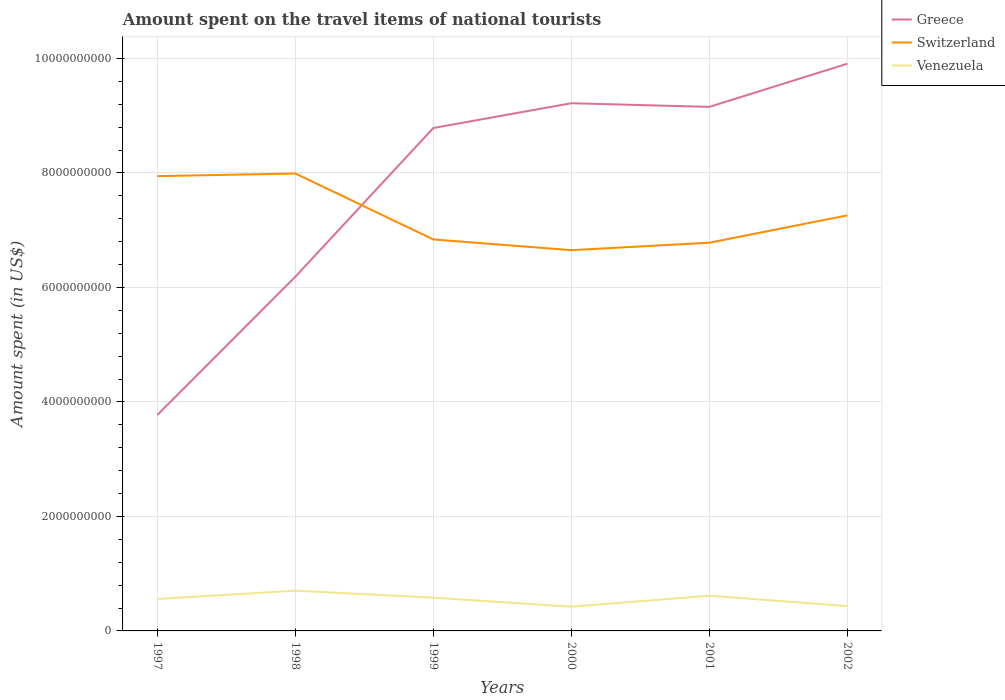How many different coloured lines are there?
Provide a short and direct response. 3. Is the number of lines equal to the number of legend labels?
Your answer should be very brief. Yes. Across all years, what is the maximum amount spent on the travel items of national tourists in Venezuela?
Your response must be concise. 4.23e+08. What is the total amount spent on the travel items of national tourists in Venezuela in the graph?
Your answer should be very brief. 2.80e+08. What is the difference between the highest and the second highest amount spent on the travel items of national tourists in Greece?
Your answer should be compact. 6.14e+09. How many lines are there?
Keep it short and to the point. 3. What is the difference between two consecutive major ticks on the Y-axis?
Provide a short and direct response. 2.00e+09. Are the values on the major ticks of Y-axis written in scientific E-notation?
Offer a terse response. No. Does the graph contain grids?
Keep it short and to the point. Yes. How many legend labels are there?
Provide a short and direct response. 3. What is the title of the graph?
Offer a terse response. Amount spent on the travel items of national tourists. Does "Cayman Islands" appear as one of the legend labels in the graph?
Give a very brief answer. No. What is the label or title of the X-axis?
Make the answer very short. Years. What is the label or title of the Y-axis?
Your answer should be compact. Amount spent (in US$). What is the Amount spent (in US$) of Greece in 1997?
Offer a very short reply. 3.77e+09. What is the Amount spent (in US$) in Switzerland in 1997?
Provide a short and direct response. 7.94e+09. What is the Amount spent (in US$) of Venezuela in 1997?
Provide a short and direct response. 5.58e+08. What is the Amount spent (in US$) of Greece in 1998?
Offer a very short reply. 6.19e+09. What is the Amount spent (in US$) in Switzerland in 1998?
Ensure brevity in your answer.  7.99e+09. What is the Amount spent (in US$) in Venezuela in 1998?
Your answer should be compact. 7.03e+08. What is the Amount spent (in US$) in Greece in 1999?
Provide a succinct answer. 8.79e+09. What is the Amount spent (in US$) in Switzerland in 1999?
Offer a terse response. 6.84e+09. What is the Amount spent (in US$) in Venezuela in 1999?
Your response must be concise. 5.81e+08. What is the Amount spent (in US$) of Greece in 2000?
Make the answer very short. 9.22e+09. What is the Amount spent (in US$) in Switzerland in 2000?
Provide a succinct answer. 6.65e+09. What is the Amount spent (in US$) in Venezuela in 2000?
Give a very brief answer. 4.23e+08. What is the Amount spent (in US$) of Greece in 2001?
Your answer should be compact. 9.16e+09. What is the Amount spent (in US$) in Switzerland in 2001?
Make the answer very short. 6.78e+09. What is the Amount spent (in US$) of Venezuela in 2001?
Provide a short and direct response. 6.15e+08. What is the Amount spent (in US$) in Greece in 2002?
Your response must be concise. 9.91e+09. What is the Amount spent (in US$) in Switzerland in 2002?
Your response must be concise. 7.26e+09. What is the Amount spent (in US$) of Venezuela in 2002?
Offer a very short reply. 4.34e+08. Across all years, what is the maximum Amount spent (in US$) in Greece?
Provide a short and direct response. 9.91e+09. Across all years, what is the maximum Amount spent (in US$) of Switzerland?
Your response must be concise. 7.99e+09. Across all years, what is the maximum Amount spent (in US$) in Venezuela?
Offer a terse response. 7.03e+08. Across all years, what is the minimum Amount spent (in US$) in Greece?
Your answer should be compact. 3.77e+09. Across all years, what is the minimum Amount spent (in US$) in Switzerland?
Your response must be concise. 6.65e+09. Across all years, what is the minimum Amount spent (in US$) in Venezuela?
Keep it short and to the point. 4.23e+08. What is the total Amount spent (in US$) of Greece in the graph?
Provide a short and direct response. 4.70e+1. What is the total Amount spent (in US$) in Switzerland in the graph?
Offer a terse response. 4.35e+1. What is the total Amount spent (in US$) of Venezuela in the graph?
Provide a succinct answer. 3.31e+09. What is the difference between the Amount spent (in US$) in Greece in 1997 and that in 1998?
Your answer should be compact. -2.42e+09. What is the difference between the Amount spent (in US$) of Switzerland in 1997 and that in 1998?
Offer a terse response. -4.60e+07. What is the difference between the Amount spent (in US$) in Venezuela in 1997 and that in 1998?
Provide a succinct answer. -1.45e+08. What is the difference between the Amount spent (in US$) of Greece in 1997 and that in 1999?
Provide a succinct answer. -5.01e+09. What is the difference between the Amount spent (in US$) in Switzerland in 1997 and that in 1999?
Offer a very short reply. 1.11e+09. What is the difference between the Amount spent (in US$) of Venezuela in 1997 and that in 1999?
Offer a very short reply. -2.30e+07. What is the difference between the Amount spent (in US$) of Greece in 1997 and that in 2000?
Offer a terse response. -5.45e+09. What is the difference between the Amount spent (in US$) in Switzerland in 1997 and that in 2000?
Your answer should be compact. 1.29e+09. What is the difference between the Amount spent (in US$) of Venezuela in 1997 and that in 2000?
Provide a succinct answer. 1.35e+08. What is the difference between the Amount spent (in US$) of Greece in 1997 and that in 2001?
Provide a succinct answer. -5.38e+09. What is the difference between the Amount spent (in US$) of Switzerland in 1997 and that in 2001?
Offer a terse response. 1.16e+09. What is the difference between the Amount spent (in US$) of Venezuela in 1997 and that in 2001?
Your response must be concise. -5.70e+07. What is the difference between the Amount spent (in US$) in Greece in 1997 and that in 2002?
Offer a terse response. -6.14e+09. What is the difference between the Amount spent (in US$) in Switzerland in 1997 and that in 2002?
Give a very brief answer. 6.85e+08. What is the difference between the Amount spent (in US$) in Venezuela in 1997 and that in 2002?
Your answer should be very brief. 1.24e+08. What is the difference between the Amount spent (in US$) of Greece in 1998 and that in 1999?
Ensure brevity in your answer.  -2.60e+09. What is the difference between the Amount spent (in US$) in Switzerland in 1998 and that in 1999?
Your answer should be compact. 1.15e+09. What is the difference between the Amount spent (in US$) in Venezuela in 1998 and that in 1999?
Offer a very short reply. 1.22e+08. What is the difference between the Amount spent (in US$) in Greece in 1998 and that in 2000?
Offer a very short reply. -3.03e+09. What is the difference between the Amount spent (in US$) of Switzerland in 1998 and that in 2000?
Give a very brief answer. 1.34e+09. What is the difference between the Amount spent (in US$) of Venezuela in 1998 and that in 2000?
Offer a terse response. 2.80e+08. What is the difference between the Amount spent (in US$) in Greece in 1998 and that in 2001?
Ensure brevity in your answer.  -2.97e+09. What is the difference between the Amount spent (in US$) of Switzerland in 1998 and that in 2001?
Offer a terse response. 1.21e+09. What is the difference between the Amount spent (in US$) of Venezuela in 1998 and that in 2001?
Offer a very short reply. 8.80e+07. What is the difference between the Amount spent (in US$) in Greece in 1998 and that in 2002?
Offer a very short reply. -3.72e+09. What is the difference between the Amount spent (in US$) in Switzerland in 1998 and that in 2002?
Your answer should be compact. 7.31e+08. What is the difference between the Amount spent (in US$) of Venezuela in 1998 and that in 2002?
Your answer should be very brief. 2.69e+08. What is the difference between the Amount spent (in US$) in Greece in 1999 and that in 2000?
Give a very brief answer. -4.33e+08. What is the difference between the Amount spent (in US$) of Switzerland in 1999 and that in 2000?
Give a very brief answer. 1.87e+08. What is the difference between the Amount spent (in US$) in Venezuela in 1999 and that in 2000?
Your answer should be compact. 1.58e+08. What is the difference between the Amount spent (in US$) of Greece in 1999 and that in 2001?
Provide a succinct answer. -3.69e+08. What is the difference between the Amount spent (in US$) of Switzerland in 1999 and that in 2001?
Give a very brief answer. 5.70e+07. What is the difference between the Amount spent (in US$) in Venezuela in 1999 and that in 2001?
Offer a very short reply. -3.40e+07. What is the difference between the Amount spent (in US$) of Greece in 1999 and that in 2002?
Make the answer very short. -1.12e+09. What is the difference between the Amount spent (in US$) of Switzerland in 1999 and that in 2002?
Provide a succinct answer. -4.21e+08. What is the difference between the Amount spent (in US$) of Venezuela in 1999 and that in 2002?
Your response must be concise. 1.47e+08. What is the difference between the Amount spent (in US$) in Greece in 2000 and that in 2001?
Provide a short and direct response. 6.40e+07. What is the difference between the Amount spent (in US$) of Switzerland in 2000 and that in 2001?
Provide a succinct answer. -1.30e+08. What is the difference between the Amount spent (in US$) of Venezuela in 2000 and that in 2001?
Make the answer very short. -1.92e+08. What is the difference between the Amount spent (in US$) of Greece in 2000 and that in 2002?
Give a very brief answer. -6.90e+08. What is the difference between the Amount spent (in US$) of Switzerland in 2000 and that in 2002?
Your answer should be very brief. -6.08e+08. What is the difference between the Amount spent (in US$) of Venezuela in 2000 and that in 2002?
Your response must be concise. -1.10e+07. What is the difference between the Amount spent (in US$) in Greece in 2001 and that in 2002?
Give a very brief answer. -7.54e+08. What is the difference between the Amount spent (in US$) in Switzerland in 2001 and that in 2002?
Keep it short and to the point. -4.78e+08. What is the difference between the Amount spent (in US$) in Venezuela in 2001 and that in 2002?
Your answer should be compact. 1.81e+08. What is the difference between the Amount spent (in US$) of Greece in 1997 and the Amount spent (in US$) of Switzerland in 1998?
Make the answer very short. -4.22e+09. What is the difference between the Amount spent (in US$) in Greece in 1997 and the Amount spent (in US$) in Venezuela in 1998?
Give a very brief answer. 3.07e+09. What is the difference between the Amount spent (in US$) of Switzerland in 1997 and the Amount spent (in US$) of Venezuela in 1998?
Your answer should be compact. 7.24e+09. What is the difference between the Amount spent (in US$) in Greece in 1997 and the Amount spent (in US$) in Switzerland in 1999?
Offer a very short reply. -3.07e+09. What is the difference between the Amount spent (in US$) in Greece in 1997 and the Amount spent (in US$) in Venezuela in 1999?
Offer a very short reply. 3.19e+09. What is the difference between the Amount spent (in US$) of Switzerland in 1997 and the Amount spent (in US$) of Venezuela in 1999?
Provide a short and direct response. 7.36e+09. What is the difference between the Amount spent (in US$) of Greece in 1997 and the Amount spent (in US$) of Switzerland in 2000?
Provide a succinct answer. -2.88e+09. What is the difference between the Amount spent (in US$) in Greece in 1997 and the Amount spent (in US$) in Venezuela in 2000?
Give a very brief answer. 3.35e+09. What is the difference between the Amount spent (in US$) of Switzerland in 1997 and the Amount spent (in US$) of Venezuela in 2000?
Your response must be concise. 7.52e+09. What is the difference between the Amount spent (in US$) in Greece in 1997 and the Amount spent (in US$) in Switzerland in 2001?
Your answer should be compact. -3.01e+09. What is the difference between the Amount spent (in US$) in Greece in 1997 and the Amount spent (in US$) in Venezuela in 2001?
Your answer should be compact. 3.16e+09. What is the difference between the Amount spent (in US$) in Switzerland in 1997 and the Amount spent (in US$) in Venezuela in 2001?
Offer a terse response. 7.33e+09. What is the difference between the Amount spent (in US$) of Greece in 1997 and the Amount spent (in US$) of Switzerland in 2002?
Make the answer very short. -3.49e+09. What is the difference between the Amount spent (in US$) of Greece in 1997 and the Amount spent (in US$) of Venezuela in 2002?
Offer a very short reply. 3.34e+09. What is the difference between the Amount spent (in US$) in Switzerland in 1997 and the Amount spent (in US$) in Venezuela in 2002?
Provide a succinct answer. 7.51e+09. What is the difference between the Amount spent (in US$) of Greece in 1998 and the Amount spent (in US$) of Switzerland in 1999?
Keep it short and to the point. -6.51e+08. What is the difference between the Amount spent (in US$) of Greece in 1998 and the Amount spent (in US$) of Venezuela in 1999?
Your answer should be very brief. 5.61e+09. What is the difference between the Amount spent (in US$) in Switzerland in 1998 and the Amount spent (in US$) in Venezuela in 1999?
Your response must be concise. 7.41e+09. What is the difference between the Amount spent (in US$) of Greece in 1998 and the Amount spent (in US$) of Switzerland in 2000?
Your answer should be compact. -4.64e+08. What is the difference between the Amount spent (in US$) of Greece in 1998 and the Amount spent (in US$) of Venezuela in 2000?
Keep it short and to the point. 5.76e+09. What is the difference between the Amount spent (in US$) in Switzerland in 1998 and the Amount spent (in US$) in Venezuela in 2000?
Keep it short and to the point. 7.57e+09. What is the difference between the Amount spent (in US$) in Greece in 1998 and the Amount spent (in US$) in Switzerland in 2001?
Provide a succinct answer. -5.94e+08. What is the difference between the Amount spent (in US$) of Greece in 1998 and the Amount spent (in US$) of Venezuela in 2001?
Your response must be concise. 5.57e+09. What is the difference between the Amount spent (in US$) in Switzerland in 1998 and the Amount spent (in US$) in Venezuela in 2001?
Make the answer very short. 7.38e+09. What is the difference between the Amount spent (in US$) in Greece in 1998 and the Amount spent (in US$) in Switzerland in 2002?
Ensure brevity in your answer.  -1.07e+09. What is the difference between the Amount spent (in US$) of Greece in 1998 and the Amount spent (in US$) of Venezuela in 2002?
Your response must be concise. 5.75e+09. What is the difference between the Amount spent (in US$) in Switzerland in 1998 and the Amount spent (in US$) in Venezuela in 2002?
Offer a terse response. 7.56e+09. What is the difference between the Amount spent (in US$) of Greece in 1999 and the Amount spent (in US$) of Switzerland in 2000?
Give a very brief answer. 2.13e+09. What is the difference between the Amount spent (in US$) of Greece in 1999 and the Amount spent (in US$) of Venezuela in 2000?
Give a very brief answer. 8.36e+09. What is the difference between the Amount spent (in US$) in Switzerland in 1999 and the Amount spent (in US$) in Venezuela in 2000?
Ensure brevity in your answer.  6.42e+09. What is the difference between the Amount spent (in US$) in Greece in 1999 and the Amount spent (in US$) in Switzerland in 2001?
Ensure brevity in your answer.  2.00e+09. What is the difference between the Amount spent (in US$) of Greece in 1999 and the Amount spent (in US$) of Venezuela in 2001?
Your answer should be very brief. 8.17e+09. What is the difference between the Amount spent (in US$) in Switzerland in 1999 and the Amount spent (in US$) in Venezuela in 2001?
Your response must be concise. 6.22e+09. What is the difference between the Amount spent (in US$) of Greece in 1999 and the Amount spent (in US$) of Switzerland in 2002?
Ensure brevity in your answer.  1.53e+09. What is the difference between the Amount spent (in US$) in Greece in 1999 and the Amount spent (in US$) in Venezuela in 2002?
Offer a terse response. 8.35e+09. What is the difference between the Amount spent (in US$) in Switzerland in 1999 and the Amount spent (in US$) in Venezuela in 2002?
Provide a succinct answer. 6.40e+09. What is the difference between the Amount spent (in US$) in Greece in 2000 and the Amount spent (in US$) in Switzerland in 2001?
Offer a very short reply. 2.44e+09. What is the difference between the Amount spent (in US$) of Greece in 2000 and the Amount spent (in US$) of Venezuela in 2001?
Your answer should be very brief. 8.60e+09. What is the difference between the Amount spent (in US$) of Switzerland in 2000 and the Amount spent (in US$) of Venezuela in 2001?
Your answer should be very brief. 6.04e+09. What is the difference between the Amount spent (in US$) in Greece in 2000 and the Amount spent (in US$) in Switzerland in 2002?
Your answer should be compact. 1.96e+09. What is the difference between the Amount spent (in US$) of Greece in 2000 and the Amount spent (in US$) of Venezuela in 2002?
Ensure brevity in your answer.  8.78e+09. What is the difference between the Amount spent (in US$) in Switzerland in 2000 and the Amount spent (in US$) in Venezuela in 2002?
Keep it short and to the point. 6.22e+09. What is the difference between the Amount spent (in US$) of Greece in 2001 and the Amount spent (in US$) of Switzerland in 2002?
Provide a succinct answer. 1.90e+09. What is the difference between the Amount spent (in US$) of Greece in 2001 and the Amount spent (in US$) of Venezuela in 2002?
Give a very brief answer. 8.72e+09. What is the difference between the Amount spent (in US$) in Switzerland in 2001 and the Amount spent (in US$) in Venezuela in 2002?
Your response must be concise. 6.35e+09. What is the average Amount spent (in US$) in Greece per year?
Keep it short and to the point. 7.84e+09. What is the average Amount spent (in US$) in Switzerland per year?
Ensure brevity in your answer.  7.24e+09. What is the average Amount spent (in US$) of Venezuela per year?
Your response must be concise. 5.52e+08. In the year 1997, what is the difference between the Amount spent (in US$) in Greece and Amount spent (in US$) in Switzerland?
Make the answer very short. -4.17e+09. In the year 1997, what is the difference between the Amount spent (in US$) in Greece and Amount spent (in US$) in Venezuela?
Provide a short and direct response. 3.22e+09. In the year 1997, what is the difference between the Amount spent (in US$) of Switzerland and Amount spent (in US$) of Venezuela?
Keep it short and to the point. 7.39e+09. In the year 1998, what is the difference between the Amount spent (in US$) of Greece and Amount spent (in US$) of Switzerland?
Ensure brevity in your answer.  -1.80e+09. In the year 1998, what is the difference between the Amount spent (in US$) in Greece and Amount spent (in US$) in Venezuela?
Your answer should be compact. 5.48e+09. In the year 1998, what is the difference between the Amount spent (in US$) in Switzerland and Amount spent (in US$) in Venezuela?
Your response must be concise. 7.29e+09. In the year 1999, what is the difference between the Amount spent (in US$) in Greece and Amount spent (in US$) in Switzerland?
Make the answer very short. 1.95e+09. In the year 1999, what is the difference between the Amount spent (in US$) of Greece and Amount spent (in US$) of Venezuela?
Your answer should be compact. 8.20e+09. In the year 1999, what is the difference between the Amount spent (in US$) of Switzerland and Amount spent (in US$) of Venezuela?
Ensure brevity in your answer.  6.26e+09. In the year 2000, what is the difference between the Amount spent (in US$) of Greece and Amount spent (in US$) of Switzerland?
Offer a very short reply. 2.57e+09. In the year 2000, what is the difference between the Amount spent (in US$) in Greece and Amount spent (in US$) in Venezuela?
Make the answer very short. 8.80e+09. In the year 2000, what is the difference between the Amount spent (in US$) in Switzerland and Amount spent (in US$) in Venezuela?
Offer a very short reply. 6.23e+09. In the year 2001, what is the difference between the Amount spent (in US$) in Greece and Amount spent (in US$) in Switzerland?
Your response must be concise. 2.37e+09. In the year 2001, what is the difference between the Amount spent (in US$) in Greece and Amount spent (in US$) in Venezuela?
Keep it short and to the point. 8.54e+09. In the year 2001, what is the difference between the Amount spent (in US$) of Switzerland and Amount spent (in US$) of Venezuela?
Offer a very short reply. 6.17e+09. In the year 2002, what is the difference between the Amount spent (in US$) of Greece and Amount spent (in US$) of Switzerland?
Give a very brief answer. 2.65e+09. In the year 2002, what is the difference between the Amount spent (in US$) in Greece and Amount spent (in US$) in Venezuela?
Provide a succinct answer. 9.48e+09. In the year 2002, what is the difference between the Amount spent (in US$) in Switzerland and Amount spent (in US$) in Venezuela?
Offer a terse response. 6.83e+09. What is the ratio of the Amount spent (in US$) in Greece in 1997 to that in 1998?
Give a very brief answer. 0.61. What is the ratio of the Amount spent (in US$) of Switzerland in 1997 to that in 1998?
Provide a succinct answer. 0.99. What is the ratio of the Amount spent (in US$) in Venezuela in 1997 to that in 1998?
Your response must be concise. 0.79. What is the ratio of the Amount spent (in US$) in Greece in 1997 to that in 1999?
Offer a terse response. 0.43. What is the ratio of the Amount spent (in US$) of Switzerland in 1997 to that in 1999?
Ensure brevity in your answer.  1.16. What is the ratio of the Amount spent (in US$) of Venezuela in 1997 to that in 1999?
Give a very brief answer. 0.96. What is the ratio of the Amount spent (in US$) in Greece in 1997 to that in 2000?
Offer a terse response. 0.41. What is the ratio of the Amount spent (in US$) in Switzerland in 1997 to that in 2000?
Offer a very short reply. 1.19. What is the ratio of the Amount spent (in US$) in Venezuela in 1997 to that in 2000?
Keep it short and to the point. 1.32. What is the ratio of the Amount spent (in US$) in Greece in 1997 to that in 2001?
Make the answer very short. 0.41. What is the ratio of the Amount spent (in US$) in Switzerland in 1997 to that in 2001?
Make the answer very short. 1.17. What is the ratio of the Amount spent (in US$) of Venezuela in 1997 to that in 2001?
Make the answer very short. 0.91. What is the ratio of the Amount spent (in US$) in Greece in 1997 to that in 2002?
Offer a very short reply. 0.38. What is the ratio of the Amount spent (in US$) in Switzerland in 1997 to that in 2002?
Make the answer very short. 1.09. What is the ratio of the Amount spent (in US$) in Venezuela in 1997 to that in 2002?
Ensure brevity in your answer.  1.29. What is the ratio of the Amount spent (in US$) of Greece in 1998 to that in 1999?
Your answer should be very brief. 0.7. What is the ratio of the Amount spent (in US$) in Switzerland in 1998 to that in 1999?
Provide a succinct answer. 1.17. What is the ratio of the Amount spent (in US$) of Venezuela in 1998 to that in 1999?
Your answer should be compact. 1.21. What is the ratio of the Amount spent (in US$) of Greece in 1998 to that in 2000?
Ensure brevity in your answer.  0.67. What is the ratio of the Amount spent (in US$) of Switzerland in 1998 to that in 2000?
Offer a very short reply. 1.2. What is the ratio of the Amount spent (in US$) in Venezuela in 1998 to that in 2000?
Your answer should be very brief. 1.66. What is the ratio of the Amount spent (in US$) of Greece in 1998 to that in 2001?
Your answer should be very brief. 0.68. What is the ratio of the Amount spent (in US$) of Switzerland in 1998 to that in 2001?
Ensure brevity in your answer.  1.18. What is the ratio of the Amount spent (in US$) of Venezuela in 1998 to that in 2001?
Your answer should be compact. 1.14. What is the ratio of the Amount spent (in US$) of Greece in 1998 to that in 2002?
Offer a very short reply. 0.62. What is the ratio of the Amount spent (in US$) in Switzerland in 1998 to that in 2002?
Ensure brevity in your answer.  1.1. What is the ratio of the Amount spent (in US$) in Venezuela in 1998 to that in 2002?
Give a very brief answer. 1.62. What is the ratio of the Amount spent (in US$) of Greece in 1999 to that in 2000?
Offer a very short reply. 0.95. What is the ratio of the Amount spent (in US$) in Switzerland in 1999 to that in 2000?
Offer a terse response. 1.03. What is the ratio of the Amount spent (in US$) of Venezuela in 1999 to that in 2000?
Your response must be concise. 1.37. What is the ratio of the Amount spent (in US$) of Greece in 1999 to that in 2001?
Provide a succinct answer. 0.96. What is the ratio of the Amount spent (in US$) of Switzerland in 1999 to that in 2001?
Offer a terse response. 1.01. What is the ratio of the Amount spent (in US$) of Venezuela in 1999 to that in 2001?
Your answer should be very brief. 0.94. What is the ratio of the Amount spent (in US$) of Greece in 1999 to that in 2002?
Your response must be concise. 0.89. What is the ratio of the Amount spent (in US$) of Switzerland in 1999 to that in 2002?
Ensure brevity in your answer.  0.94. What is the ratio of the Amount spent (in US$) of Venezuela in 1999 to that in 2002?
Provide a short and direct response. 1.34. What is the ratio of the Amount spent (in US$) in Greece in 2000 to that in 2001?
Your answer should be compact. 1.01. What is the ratio of the Amount spent (in US$) in Switzerland in 2000 to that in 2001?
Offer a very short reply. 0.98. What is the ratio of the Amount spent (in US$) of Venezuela in 2000 to that in 2001?
Provide a short and direct response. 0.69. What is the ratio of the Amount spent (in US$) of Greece in 2000 to that in 2002?
Your answer should be very brief. 0.93. What is the ratio of the Amount spent (in US$) of Switzerland in 2000 to that in 2002?
Ensure brevity in your answer.  0.92. What is the ratio of the Amount spent (in US$) of Venezuela in 2000 to that in 2002?
Make the answer very short. 0.97. What is the ratio of the Amount spent (in US$) in Greece in 2001 to that in 2002?
Give a very brief answer. 0.92. What is the ratio of the Amount spent (in US$) in Switzerland in 2001 to that in 2002?
Make the answer very short. 0.93. What is the ratio of the Amount spent (in US$) of Venezuela in 2001 to that in 2002?
Your response must be concise. 1.42. What is the difference between the highest and the second highest Amount spent (in US$) of Greece?
Keep it short and to the point. 6.90e+08. What is the difference between the highest and the second highest Amount spent (in US$) in Switzerland?
Provide a succinct answer. 4.60e+07. What is the difference between the highest and the second highest Amount spent (in US$) in Venezuela?
Your answer should be very brief. 8.80e+07. What is the difference between the highest and the lowest Amount spent (in US$) in Greece?
Your answer should be very brief. 6.14e+09. What is the difference between the highest and the lowest Amount spent (in US$) of Switzerland?
Ensure brevity in your answer.  1.34e+09. What is the difference between the highest and the lowest Amount spent (in US$) in Venezuela?
Your answer should be very brief. 2.80e+08. 